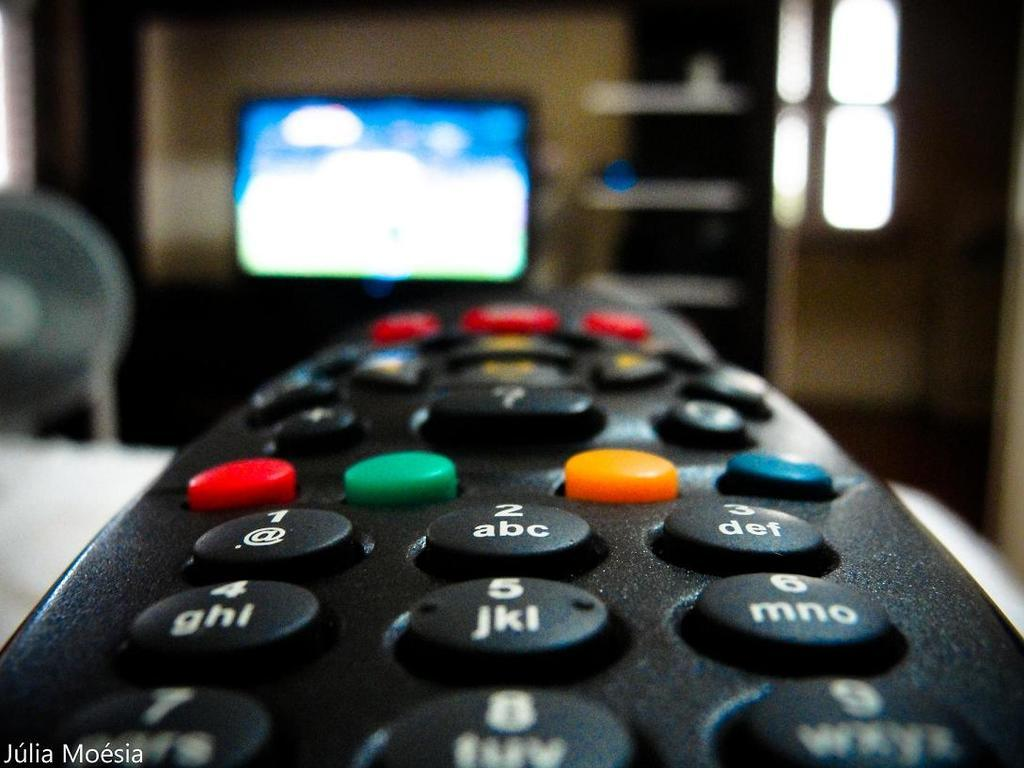<image>
Provide a brief description of the given image. close up of a remote pointed at a tv and name julia moesia in bottom corner 